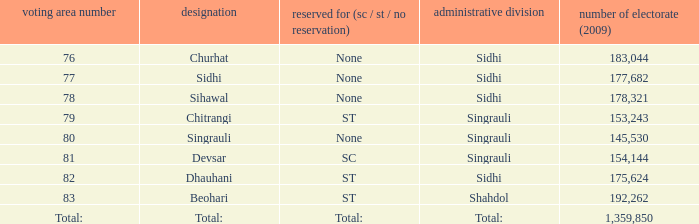Would you mind parsing the complete table? {'header': ['voting area number', 'designation', 'reserved for (sc / st / no reservation)', 'administrative division', 'number of electorate (2009)'], 'rows': [['76', 'Churhat', 'None', 'Sidhi', '183,044'], ['77', 'Sidhi', 'None', 'Sidhi', '177,682'], ['78', 'Sihawal', 'None', 'Sidhi', '178,321'], ['79', 'Chitrangi', 'ST', 'Singrauli', '153,243'], ['80', 'Singrauli', 'None', 'Singrauli', '145,530'], ['81', 'Devsar', 'SC', 'Singrauli', '154,144'], ['82', 'Dhauhani', 'ST', 'Sidhi', '175,624'], ['83', 'Beohari', 'ST', 'Shahdol', '192,262'], ['Total:', 'Total:', 'Total:', 'Total:', '1,359,850']]} What is Beohari's reserved for (SC/ST/None)? ST. 